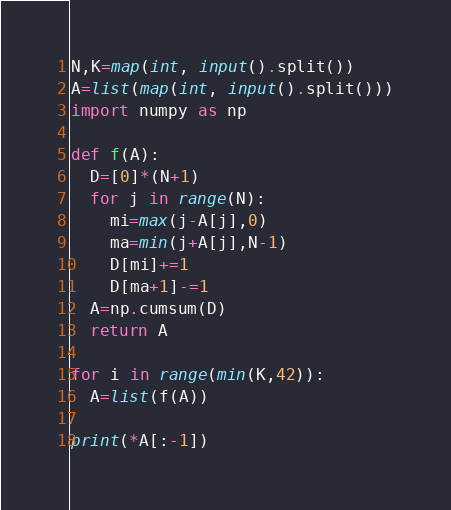<code> <loc_0><loc_0><loc_500><loc_500><_Python_>N,K=map(int, input().split())
A=list(map(int, input().split()))
import numpy as np

def f(A):
  D=[0]*(N+1)
  for j in range(N):
    mi=max(j-A[j],0)
    ma=min(j+A[j],N-1)
    D[mi]+=1
    D[ma+1]-=1   
  A=np.cumsum(D)
  return A 

for i in range(min(K,42)):
  A=list(f(A))  
  
print(*A[:-1])
</code> 